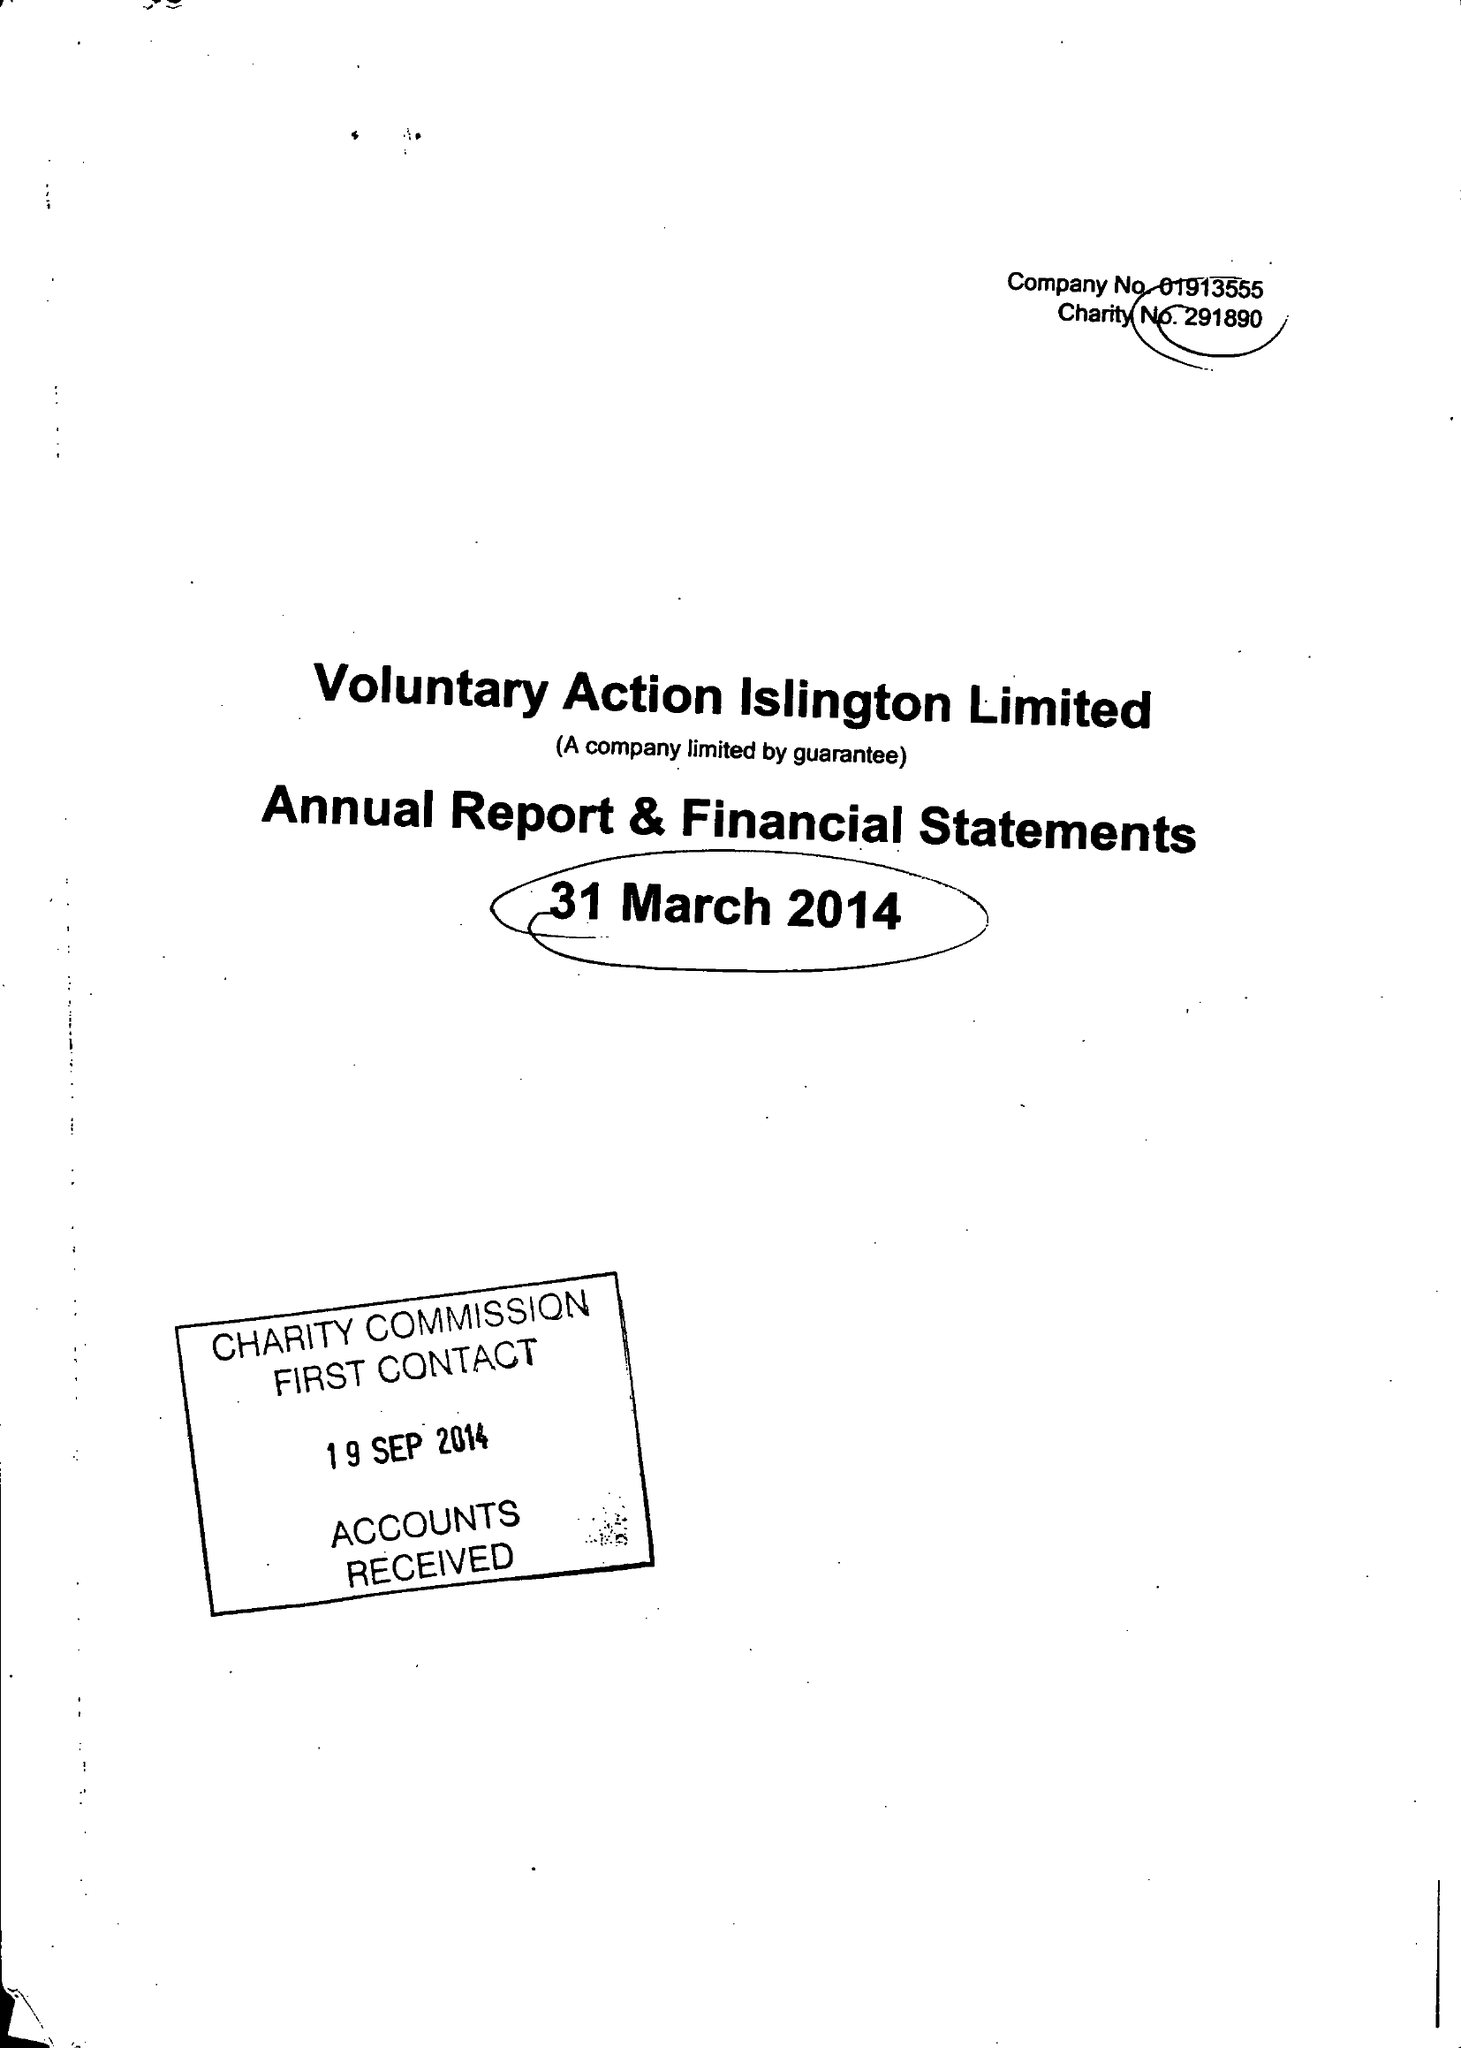What is the value for the charity_number?
Answer the question using a single word or phrase. 291890 